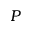Convert formula to latex. <formula><loc_0><loc_0><loc_500><loc_500>P</formula> 